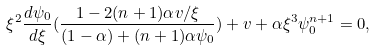Convert formula to latex. <formula><loc_0><loc_0><loc_500><loc_500>\xi ^ { 2 } \frac { d \psi _ { 0 } } { d \xi } ( \frac { 1 - 2 ( n + 1 ) \alpha v / \xi } { ( 1 - \alpha ) + ( n + 1 ) \alpha \psi _ { 0 } } ) + v + \alpha \xi ^ { 3 } \psi _ { 0 } ^ { n + 1 } = 0 ,</formula> 